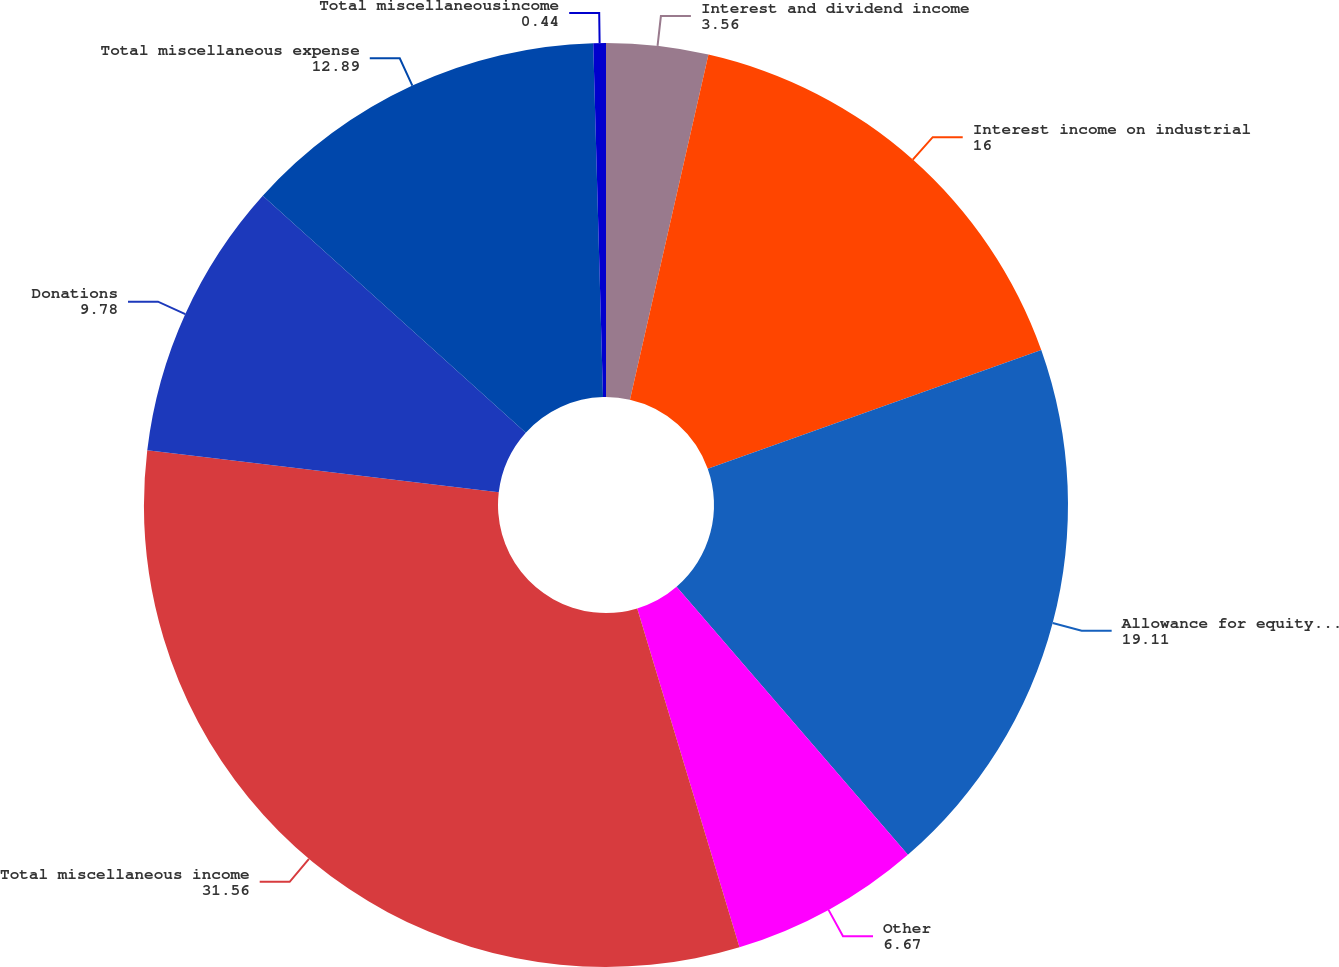Convert chart to OTSL. <chart><loc_0><loc_0><loc_500><loc_500><pie_chart><fcel>Interest and dividend income<fcel>Interest income on industrial<fcel>Allowance for equity funds<fcel>Other<fcel>Total miscellaneous income<fcel>Donations<fcel>Total miscellaneous expense<fcel>Total miscellaneousincome<nl><fcel>3.56%<fcel>16.0%<fcel>19.11%<fcel>6.67%<fcel>31.56%<fcel>9.78%<fcel>12.89%<fcel>0.44%<nl></chart> 